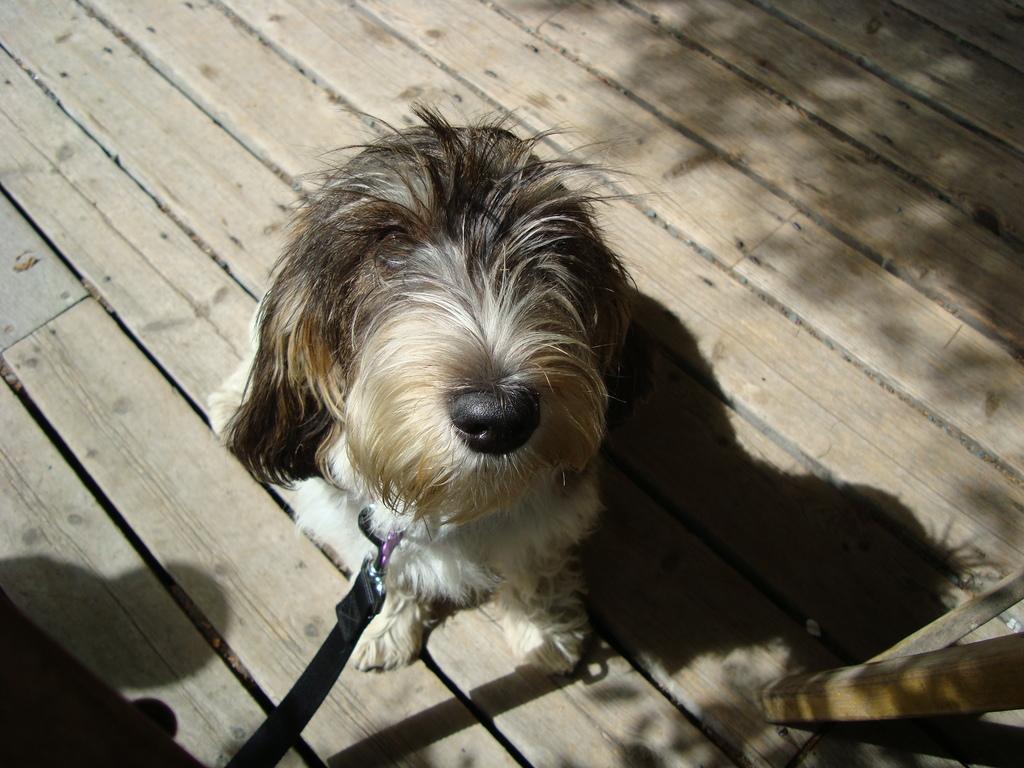Please provide a concise description of this image. In this picture we can see a dog on a wooden surface and there is a belt tied to it. 